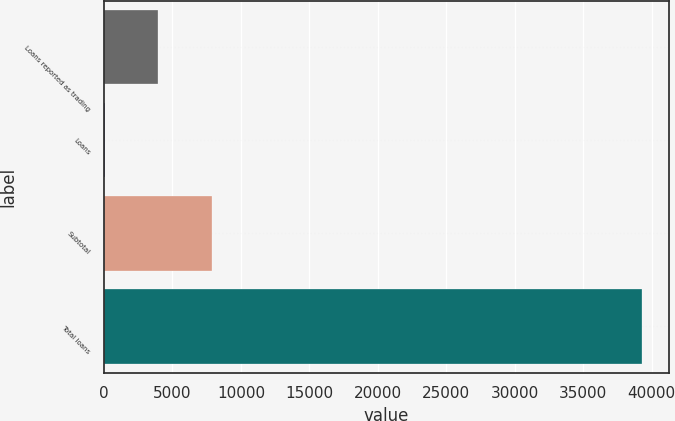<chart> <loc_0><loc_0><loc_500><loc_500><bar_chart><fcel>Loans reported as trading<fcel>Loans<fcel>Subtotal<fcel>Total loans<nl><fcel>3975.3<fcel>51<fcel>7899.6<fcel>39294<nl></chart> 